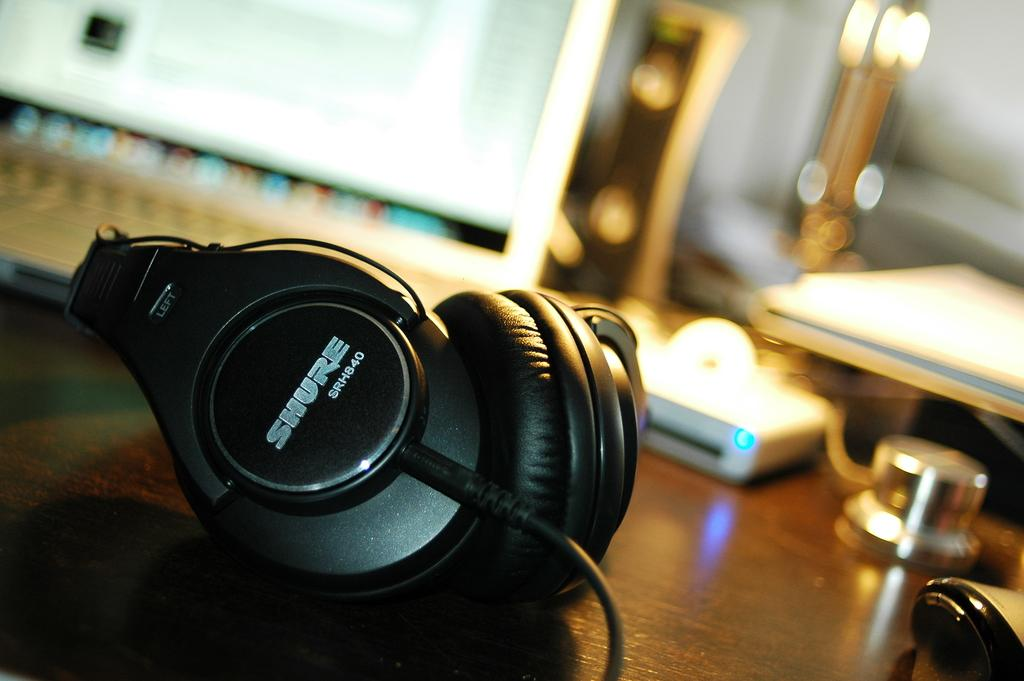What is the main object on the wooden surface in the image? There is a microphone on a wooden surface in the image. What else can be seen in the image besides the microphone? There are other objects in the image. Can you describe the background of the image? The background of the image is blurred. How many bells are hanging from the microphone in the image? There are no bells present in the image; it only shows a microphone on a wooden surface and other unspecified objects. 